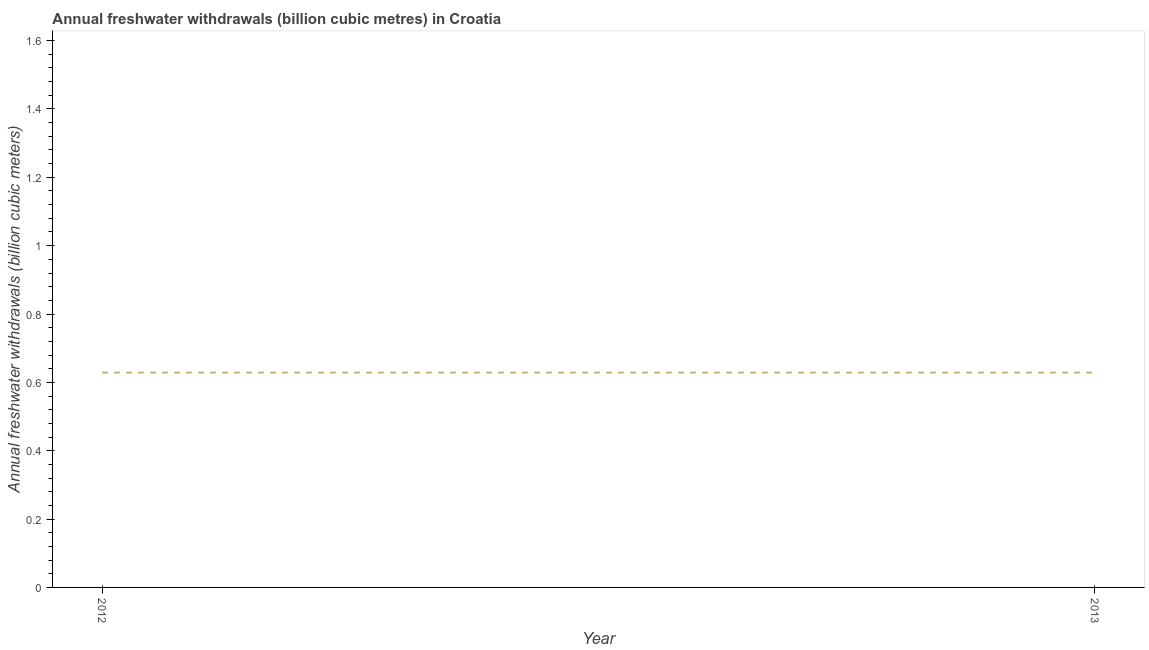What is the annual freshwater withdrawals in 2013?
Give a very brief answer. 0.63. Across all years, what is the maximum annual freshwater withdrawals?
Keep it short and to the point. 0.63. Across all years, what is the minimum annual freshwater withdrawals?
Provide a succinct answer. 0.63. In which year was the annual freshwater withdrawals maximum?
Keep it short and to the point. 2012. What is the sum of the annual freshwater withdrawals?
Give a very brief answer. 1.26. What is the average annual freshwater withdrawals per year?
Your answer should be compact. 0.63. What is the median annual freshwater withdrawals?
Offer a terse response. 0.63. Is the annual freshwater withdrawals in 2012 less than that in 2013?
Give a very brief answer. No. In how many years, is the annual freshwater withdrawals greater than the average annual freshwater withdrawals taken over all years?
Your answer should be compact. 0. Does the annual freshwater withdrawals monotonically increase over the years?
Provide a succinct answer. No. How many lines are there?
Your response must be concise. 1. Does the graph contain any zero values?
Ensure brevity in your answer.  No. Does the graph contain grids?
Offer a terse response. No. What is the title of the graph?
Make the answer very short. Annual freshwater withdrawals (billion cubic metres) in Croatia. What is the label or title of the Y-axis?
Give a very brief answer. Annual freshwater withdrawals (billion cubic meters). What is the Annual freshwater withdrawals (billion cubic meters) of 2012?
Give a very brief answer. 0.63. What is the Annual freshwater withdrawals (billion cubic meters) in 2013?
Keep it short and to the point. 0.63. What is the difference between the Annual freshwater withdrawals (billion cubic meters) in 2012 and 2013?
Offer a very short reply. 0. 